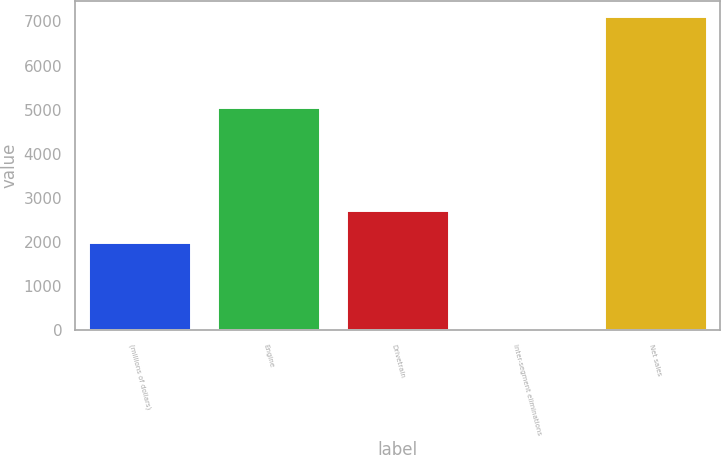Convert chart to OTSL. <chart><loc_0><loc_0><loc_500><loc_500><bar_chart><fcel>(millions of dollars)<fcel>Engine<fcel>Drivetrain<fcel>Inter-segment eliminations<fcel>Net sales<nl><fcel>2011<fcel>5050.6<fcel>2720.43<fcel>20.4<fcel>7114.7<nl></chart> 